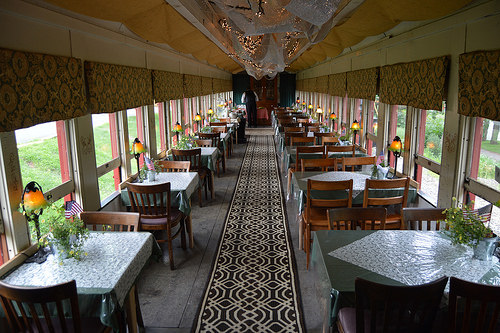<image>
Can you confirm if the lamp is next to the plant? Yes. The lamp is positioned adjacent to the plant, located nearby in the same general area. Is there a table in the grass? No. The table is not contained within the grass. These objects have a different spatial relationship. Is the window in front of the chair? No. The window is not in front of the chair. The spatial positioning shows a different relationship between these objects. 